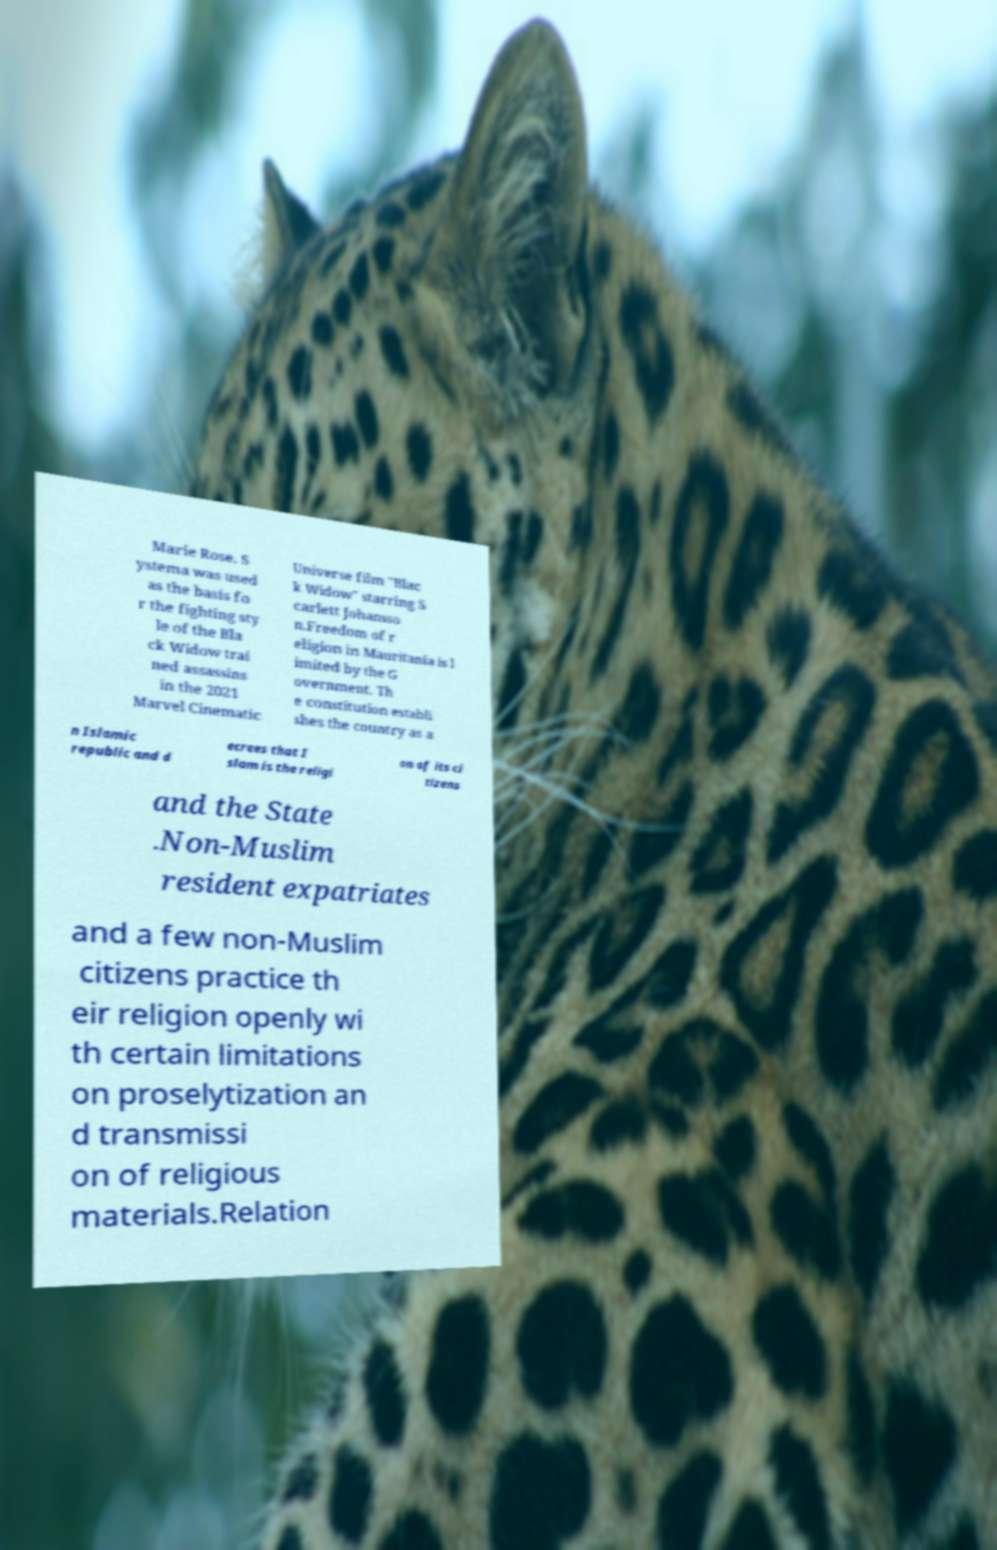There's text embedded in this image that I need extracted. Can you transcribe it verbatim? Marie Rose. S ystema was used as the basis fo r the fighting sty le of the Bla ck Widow trai ned assassins in the 2021 Marvel Cinematic Universe film "Blac k Widow" starring S carlett Johansso n.Freedom of r eligion in Mauritania is l imited by the G overnment. Th e constitution establi shes the country as a n Islamic republic and d ecrees that I slam is the religi on of its ci tizens and the State .Non-Muslim resident expatriates and a few non-Muslim citizens practice th eir religion openly wi th certain limitations on proselytization an d transmissi on of religious materials.Relation 